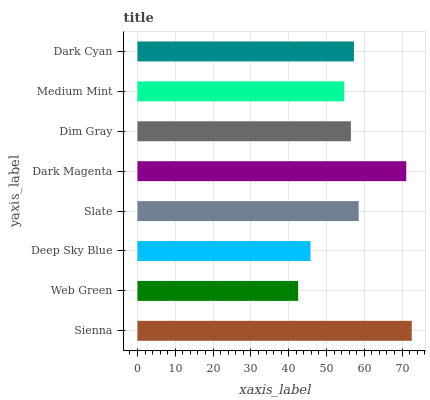Is Web Green the minimum?
Answer yes or no. Yes. Is Sienna the maximum?
Answer yes or no. Yes. Is Deep Sky Blue the minimum?
Answer yes or no. No. Is Deep Sky Blue the maximum?
Answer yes or no. No. Is Deep Sky Blue greater than Web Green?
Answer yes or no. Yes. Is Web Green less than Deep Sky Blue?
Answer yes or no. Yes. Is Web Green greater than Deep Sky Blue?
Answer yes or no. No. Is Deep Sky Blue less than Web Green?
Answer yes or no. No. Is Dark Cyan the high median?
Answer yes or no. Yes. Is Dim Gray the low median?
Answer yes or no. Yes. Is Medium Mint the high median?
Answer yes or no. No. Is Sienna the low median?
Answer yes or no. No. 